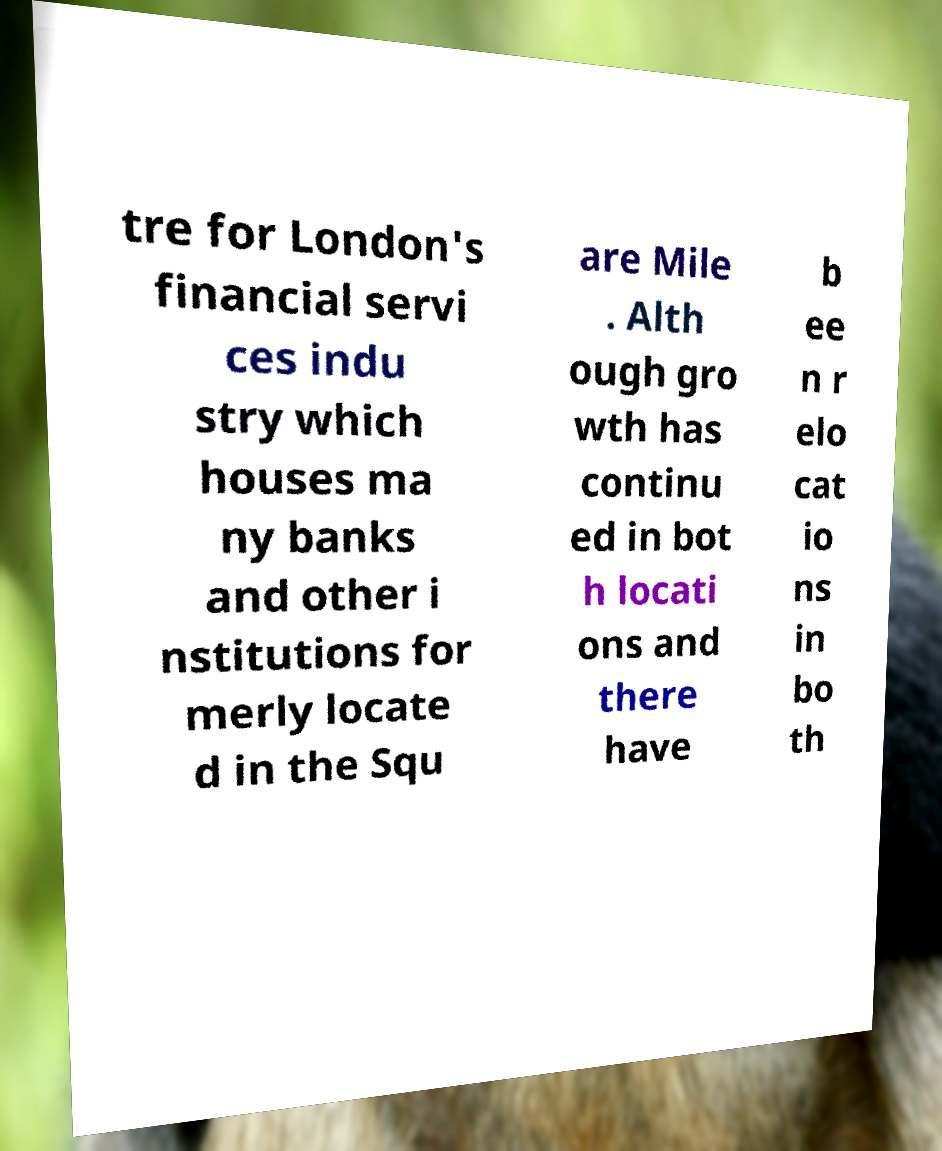For documentation purposes, I need the text within this image transcribed. Could you provide that? tre for London's financial servi ces indu stry which houses ma ny banks and other i nstitutions for merly locate d in the Squ are Mile . Alth ough gro wth has continu ed in bot h locati ons and there have b ee n r elo cat io ns in bo th 